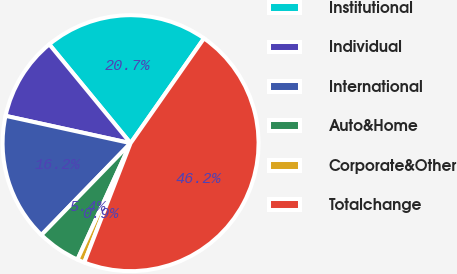Convert chart. <chart><loc_0><loc_0><loc_500><loc_500><pie_chart><fcel>Institutional<fcel>Individual<fcel>International<fcel>Auto&Home<fcel>Corporate&Other<fcel>Totalchange<nl><fcel>20.68%<fcel>10.62%<fcel>16.16%<fcel>5.45%<fcel>0.92%<fcel>46.17%<nl></chart> 